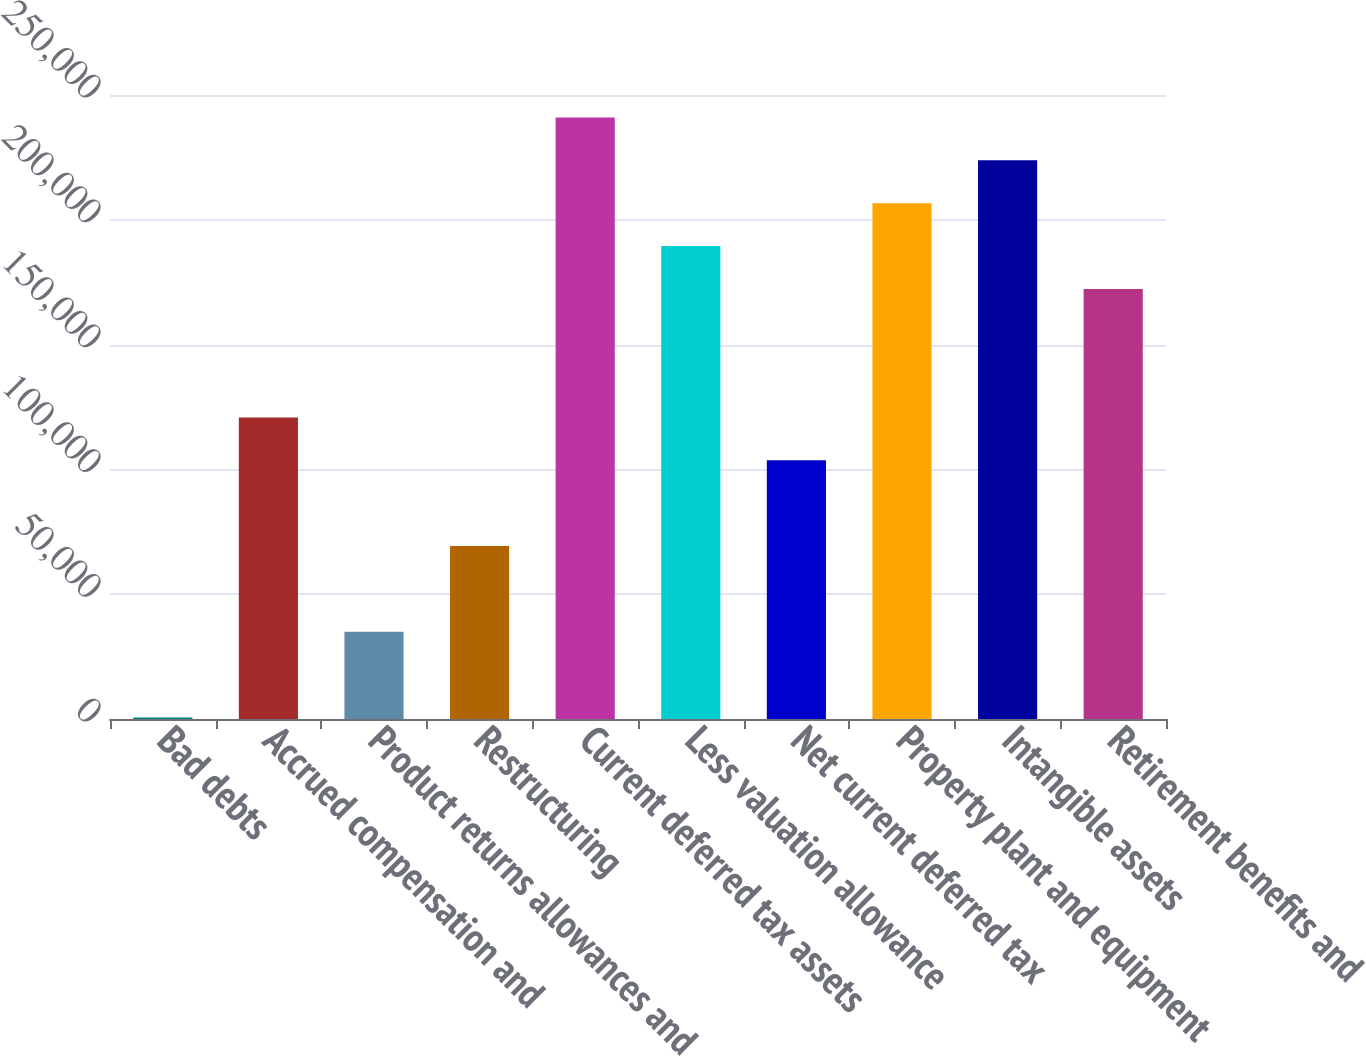Convert chart to OTSL. <chart><loc_0><loc_0><loc_500><loc_500><bar_chart><fcel>Bad debts<fcel>Accrued compensation and<fcel>Product returns allowances and<fcel>Restructuring<fcel>Current deferred tax assets<fcel>Less valuation allowance<fcel>Net current deferred tax<fcel>Property plant and equipment<fcel>Intangible assets<fcel>Retirement benefits and<nl><fcel>559<fcel>120792<fcel>34911.4<fcel>69263.8<fcel>241026<fcel>189497<fcel>103616<fcel>206673<fcel>223850<fcel>172321<nl></chart> 